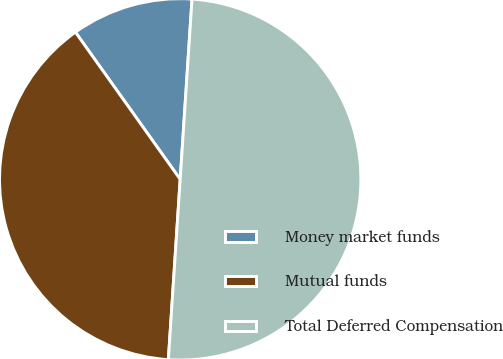<chart> <loc_0><loc_0><loc_500><loc_500><pie_chart><fcel>Money market funds<fcel>Mutual funds<fcel>Total Deferred Compensation<nl><fcel>10.89%<fcel>39.11%<fcel>50.0%<nl></chart> 